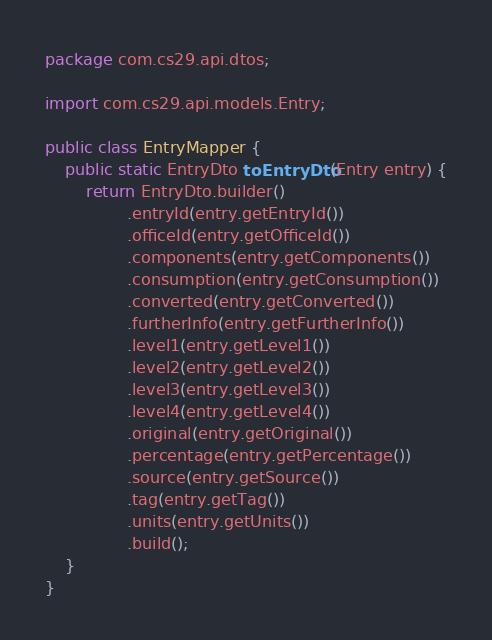<code> <loc_0><loc_0><loc_500><loc_500><_Java_>package com.cs29.api.dtos;

import com.cs29.api.models.Entry;

public class EntryMapper {
    public static EntryDto toEntryDto(Entry entry) {
        return EntryDto.builder()
                .entryId(entry.getEntryId())
                .officeId(entry.getOfficeId())
                .components(entry.getComponents())
                .consumption(entry.getConsumption())
                .converted(entry.getConverted())
                .furtherInfo(entry.getFurtherInfo())
                .level1(entry.getLevel1())
                .level2(entry.getLevel2())
                .level3(entry.getLevel3())
                .level4(entry.getLevel4())
                .original(entry.getOriginal())
                .percentage(entry.getPercentage())
                .source(entry.getSource())
                .tag(entry.getTag())
                .units(entry.getUnits())
                .build();
    }
}
</code> 